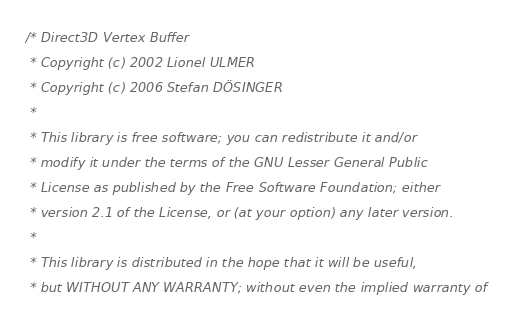Convert code to text. <code><loc_0><loc_0><loc_500><loc_500><_C_>/* Direct3D Vertex Buffer
 * Copyright (c) 2002 Lionel ULMER
 * Copyright (c) 2006 Stefan DÖSINGER
 *
 * This library is free software; you can redistribute it and/or
 * modify it under the terms of the GNU Lesser General Public
 * License as published by the Free Software Foundation; either
 * version 2.1 of the License, or (at your option) any later version.
 *
 * This library is distributed in the hope that it will be useful,
 * but WITHOUT ANY WARRANTY; without even the implied warranty of</code> 